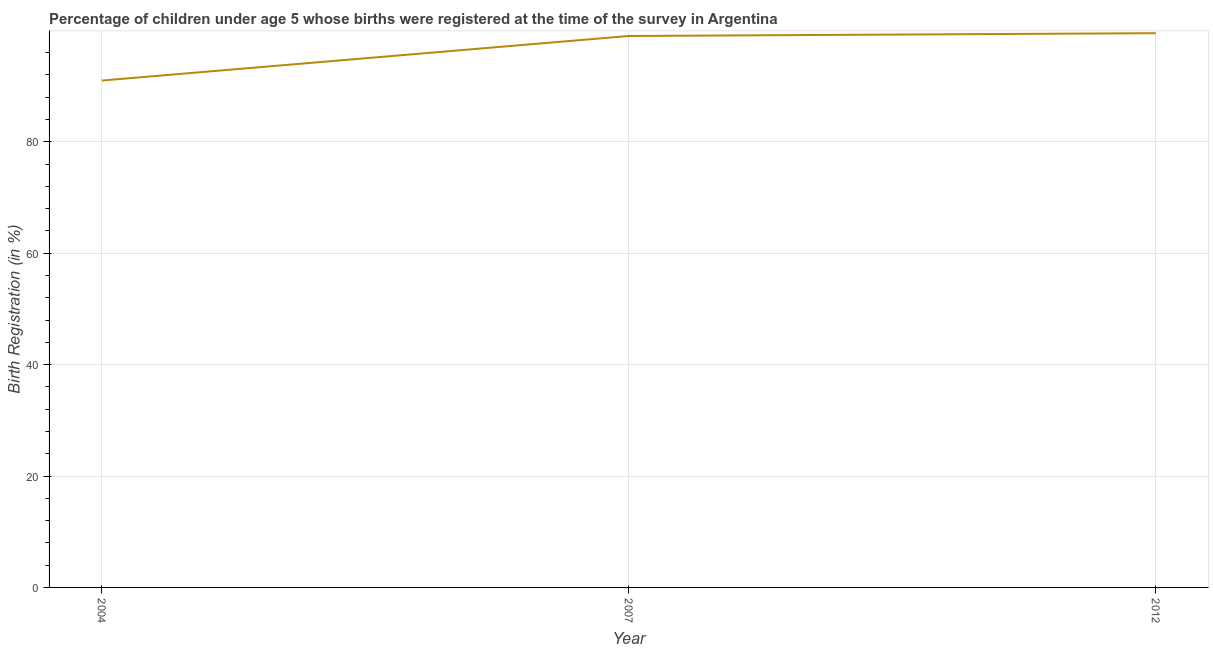Across all years, what is the maximum birth registration?
Provide a succinct answer. 99.5. Across all years, what is the minimum birth registration?
Provide a succinct answer. 91. In which year was the birth registration maximum?
Your answer should be very brief. 2012. In which year was the birth registration minimum?
Your response must be concise. 2004. What is the sum of the birth registration?
Give a very brief answer. 289.5. What is the average birth registration per year?
Provide a short and direct response. 96.5. What is the ratio of the birth registration in 2007 to that in 2012?
Keep it short and to the point. 0.99. Is the birth registration in 2007 less than that in 2012?
Offer a terse response. Yes. Is the difference between the birth registration in 2004 and 2012 greater than the difference between any two years?
Make the answer very short. Yes. What is the difference between the highest and the second highest birth registration?
Keep it short and to the point. 0.5. Is the sum of the birth registration in 2004 and 2007 greater than the maximum birth registration across all years?
Offer a terse response. Yes. In how many years, is the birth registration greater than the average birth registration taken over all years?
Your answer should be compact. 2. How many lines are there?
Your answer should be very brief. 1. How many years are there in the graph?
Your answer should be very brief. 3. What is the difference between two consecutive major ticks on the Y-axis?
Make the answer very short. 20. Does the graph contain any zero values?
Keep it short and to the point. No. What is the title of the graph?
Your response must be concise. Percentage of children under age 5 whose births were registered at the time of the survey in Argentina. What is the label or title of the Y-axis?
Your response must be concise. Birth Registration (in %). What is the Birth Registration (in %) of 2004?
Offer a very short reply. 91. What is the Birth Registration (in %) of 2007?
Offer a very short reply. 99. What is the Birth Registration (in %) in 2012?
Give a very brief answer. 99.5. What is the difference between the Birth Registration (in %) in 2004 and 2007?
Your answer should be very brief. -8. What is the ratio of the Birth Registration (in %) in 2004 to that in 2007?
Keep it short and to the point. 0.92. What is the ratio of the Birth Registration (in %) in 2004 to that in 2012?
Your answer should be compact. 0.92. What is the ratio of the Birth Registration (in %) in 2007 to that in 2012?
Your response must be concise. 0.99. 